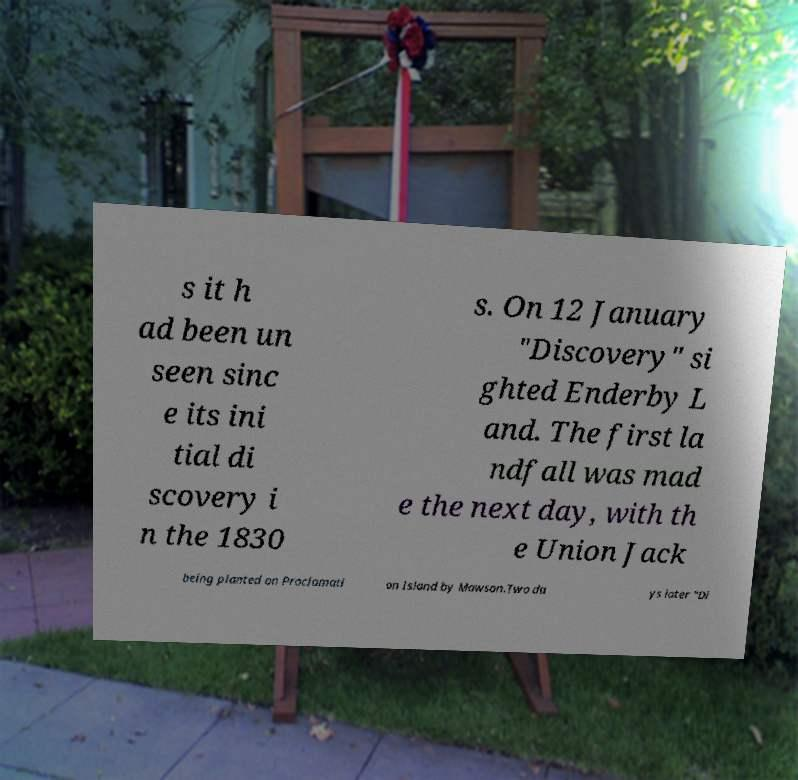Can you read and provide the text displayed in the image?This photo seems to have some interesting text. Can you extract and type it out for me? s it h ad been un seen sinc e its ini tial di scovery i n the 1830 s. On 12 January "Discovery" si ghted Enderby L and. The first la ndfall was mad e the next day, with th e Union Jack being planted on Proclamati on Island by Mawson.Two da ys later "Di 